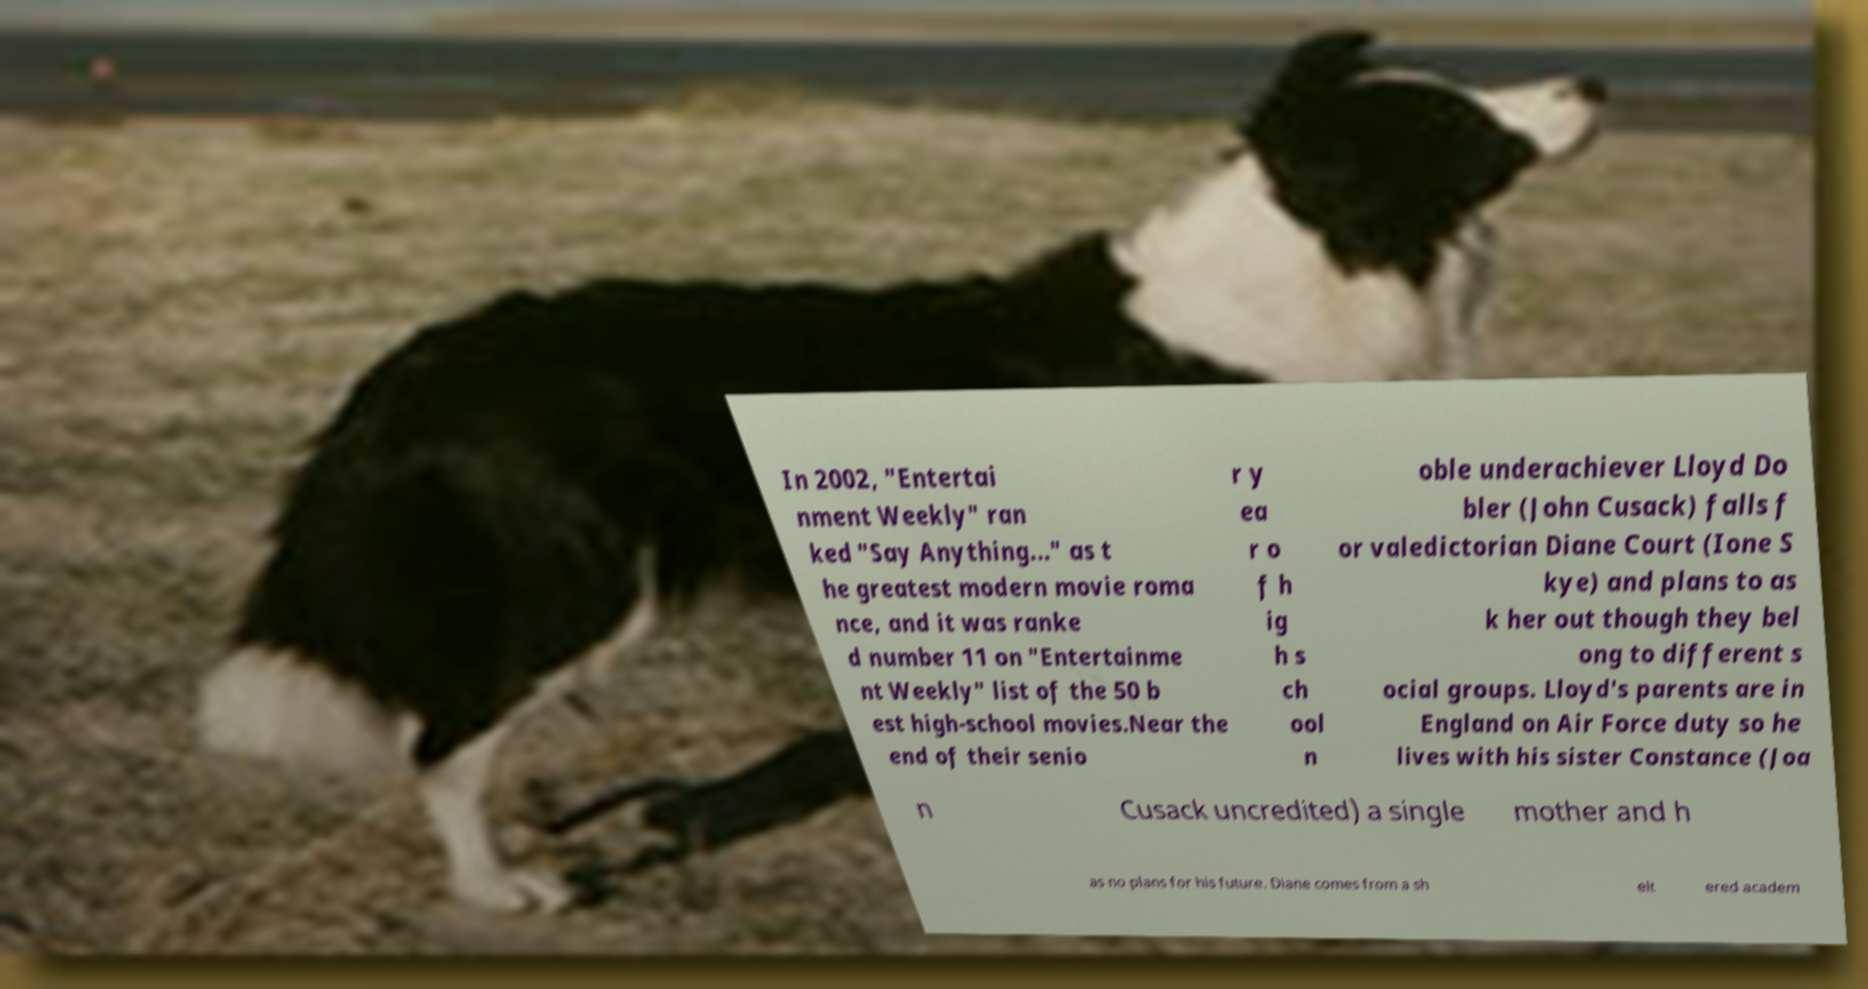Can you read and provide the text displayed in the image?This photo seems to have some interesting text. Can you extract and type it out for me? In 2002, "Entertai nment Weekly" ran ked "Say Anything..." as t he greatest modern movie roma nce, and it was ranke d number 11 on "Entertainme nt Weekly" list of the 50 b est high-school movies.Near the end of their senio r y ea r o f h ig h s ch ool n oble underachiever Lloyd Do bler (John Cusack) falls f or valedictorian Diane Court (Ione S kye) and plans to as k her out though they bel ong to different s ocial groups. Lloyd's parents are in England on Air Force duty so he lives with his sister Constance (Joa n Cusack uncredited) a single mother and h as no plans for his future. Diane comes from a sh elt ered academ 